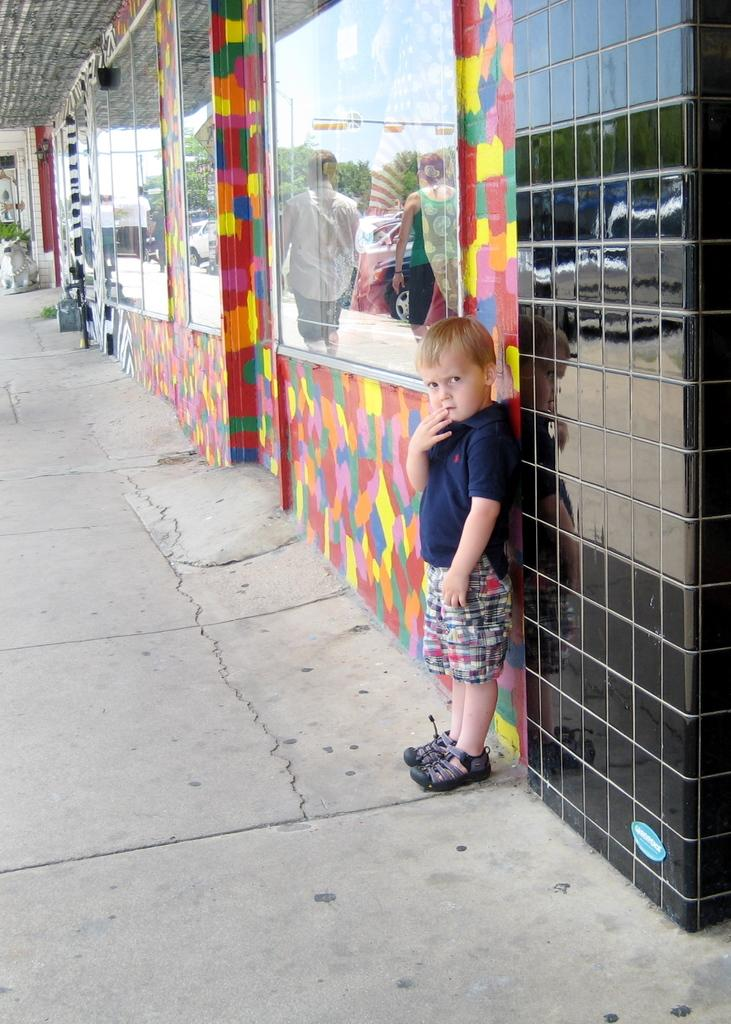Who is the main subject in the image? There is a boy in the image. What is the boy's position in the image? The boy is standing on the floor. What is behind the boy in the image? There is a wall behind the boy. What can be seen on the right side of the image? There are glass windows on the right side of the image. What type of magic is the boy performing in the image? There is no indication of magic or any magical activity in the image. Can you see a bear in the image? No, there is no bear present in the image. 